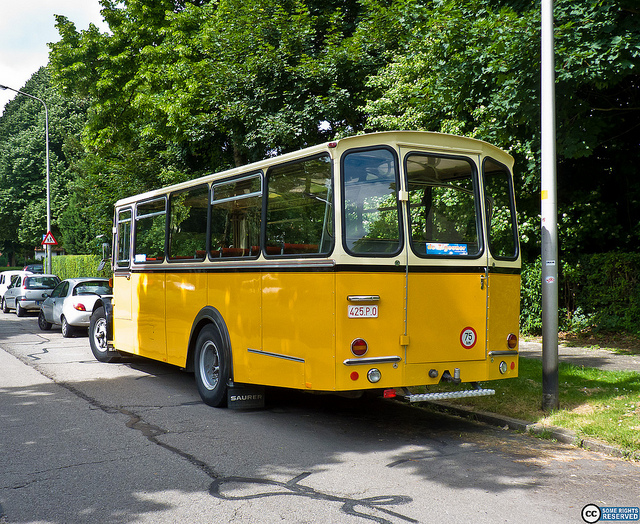Read all the text in this image. 425,P,0 75 